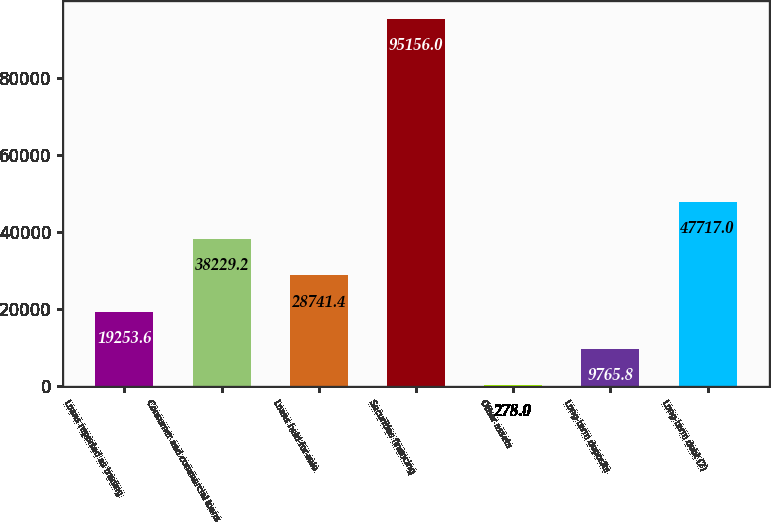Convert chart to OTSL. <chart><loc_0><loc_0><loc_500><loc_500><bar_chart><fcel>Loans reported as trading<fcel>Consumer and commercial loans<fcel>Loans held-for-sale<fcel>Securities financing<fcel>Other assets<fcel>Long-term deposits<fcel>Long-term debt (2)<nl><fcel>19253.6<fcel>38229.2<fcel>28741.4<fcel>95156<fcel>278<fcel>9765.8<fcel>47717<nl></chart> 